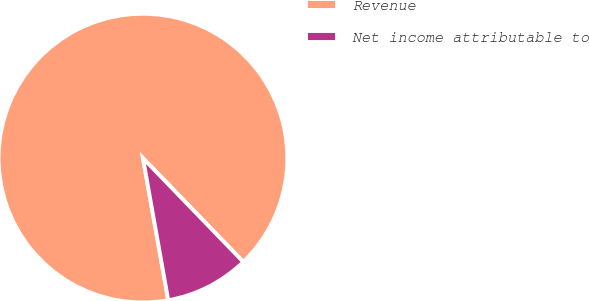<chart> <loc_0><loc_0><loc_500><loc_500><pie_chart><fcel>Revenue<fcel>Net income attributable to<nl><fcel>90.57%<fcel>9.43%<nl></chart> 